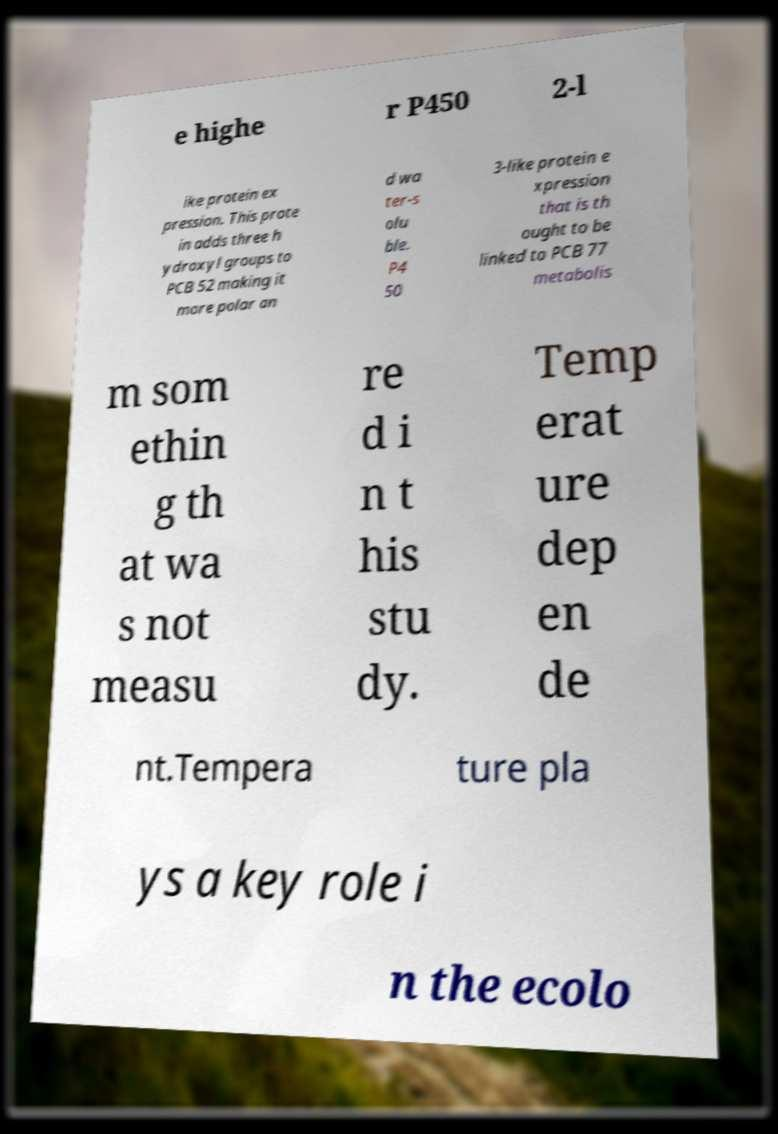Please identify and transcribe the text found in this image. e highe r P450 2-l ike protein ex pression. This prote in adds three h ydroxyl groups to PCB 52 making it more polar an d wa ter-s olu ble. P4 50 3-like protein e xpression that is th ought to be linked to PCB 77 metabolis m som ethin g th at wa s not measu re d i n t his stu dy. Temp erat ure dep en de nt.Tempera ture pla ys a key role i n the ecolo 